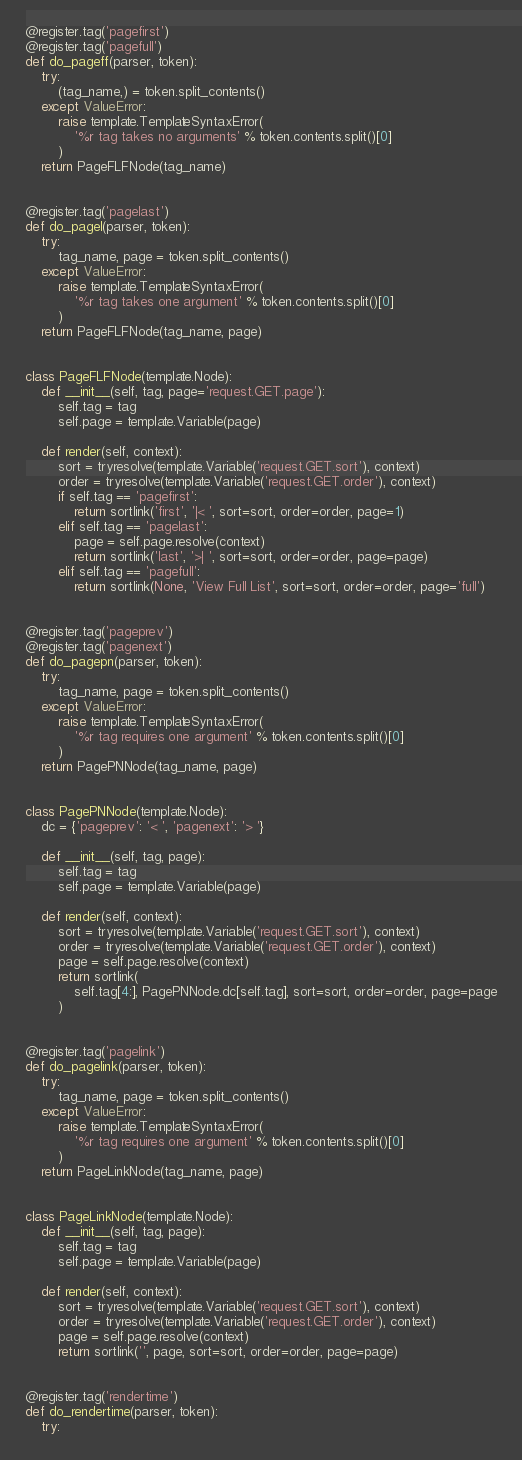<code> <loc_0><loc_0><loc_500><loc_500><_Python_>

@register.tag('pagefirst')
@register.tag('pagefull')
def do_pageff(parser, token):
    try:
        (tag_name,) = token.split_contents()
    except ValueError:
        raise template.TemplateSyntaxError(
            '%r tag takes no arguments' % token.contents.split()[0]
        )
    return PageFLFNode(tag_name)


@register.tag('pagelast')
def do_pagel(parser, token):
    try:
        tag_name, page = token.split_contents()
    except ValueError:
        raise template.TemplateSyntaxError(
            '%r tag takes one argument' % token.contents.split()[0]
        )
    return PageFLFNode(tag_name, page)


class PageFLFNode(template.Node):
    def __init__(self, tag, page='request.GET.page'):
        self.tag = tag
        self.page = template.Variable(page)

    def render(self, context):
        sort = tryresolve(template.Variable('request.GET.sort'), context)
        order = tryresolve(template.Variable('request.GET.order'), context)
        if self.tag == 'pagefirst':
            return sortlink('first', '|< ', sort=sort, order=order, page=1)
        elif self.tag == 'pagelast':
            page = self.page.resolve(context)
            return sortlink('last', '>| ', sort=sort, order=order, page=page)
        elif self.tag == 'pagefull':
            return sortlink(None, 'View Full List', sort=sort, order=order, page='full')


@register.tag('pageprev')
@register.tag('pagenext')
def do_pagepn(parser, token):
    try:
        tag_name, page = token.split_contents()
    except ValueError:
        raise template.TemplateSyntaxError(
            '%r tag requires one argument' % token.contents.split()[0]
        )
    return PagePNNode(tag_name, page)


class PagePNNode(template.Node):
    dc = {'pageprev': '< ', 'pagenext': '> '}

    def __init__(self, tag, page):
        self.tag = tag
        self.page = template.Variable(page)

    def render(self, context):
        sort = tryresolve(template.Variable('request.GET.sort'), context)
        order = tryresolve(template.Variable('request.GET.order'), context)
        page = self.page.resolve(context)
        return sortlink(
            self.tag[4:], PagePNNode.dc[self.tag], sort=sort, order=order, page=page
        )


@register.tag('pagelink')
def do_pagelink(parser, token):
    try:
        tag_name, page = token.split_contents()
    except ValueError:
        raise template.TemplateSyntaxError(
            '%r tag requires one argument' % token.contents.split()[0]
        )
    return PageLinkNode(tag_name, page)


class PageLinkNode(template.Node):
    def __init__(self, tag, page):
        self.tag = tag
        self.page = template.Variable(page)

    def render(self, context):
        sort = tryresolve(template.Variable('request.GET.sort'), context)
        order = tryresolve(template.Variable('request.GET.order'), context)
        page = self.page.resolve(context)
        return sortlink('', page, sort=sort, order=order, page=page)


@register.tag('rendertime')
def do_rendertime(parser, token):
    try:</code> 